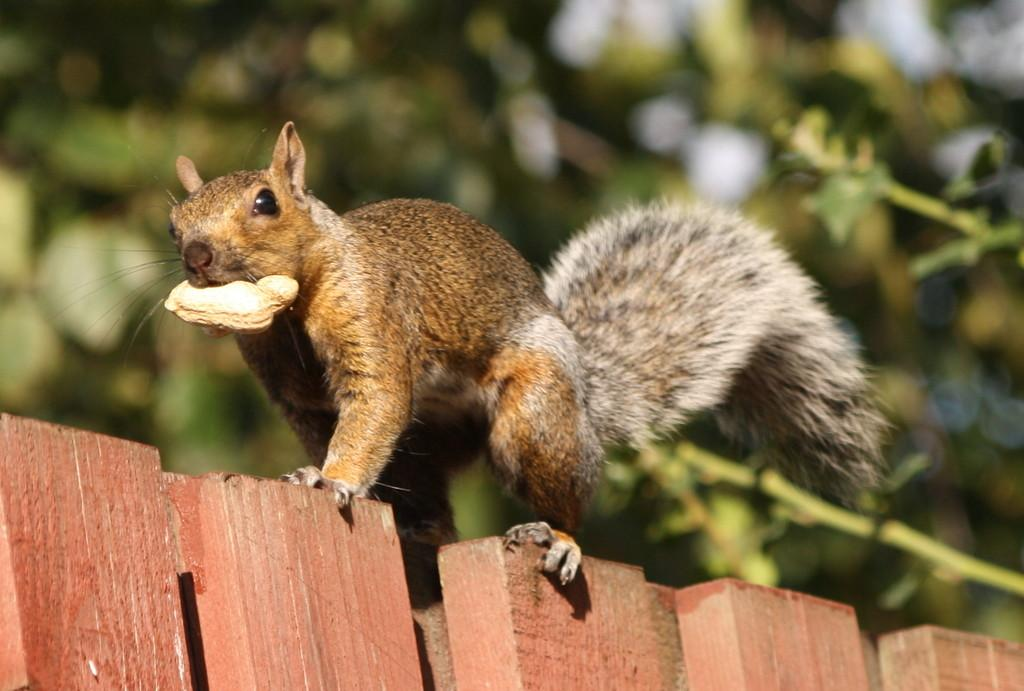What objects can be seen in the image? There are wooden sticks in the image. What is on the wooden sticks? A squirrel is present on the wooden sticks. What is the squirrel holding? The squirrel is holding a peanut. What can be seen in the background of the image? There are trees in the background of the image. How many chairs are visible in the image? There are no chairs present in the image. What type of list is the squirrel holding in the image? The squirrel is not holding a list in the image; it is holding a peanut. 